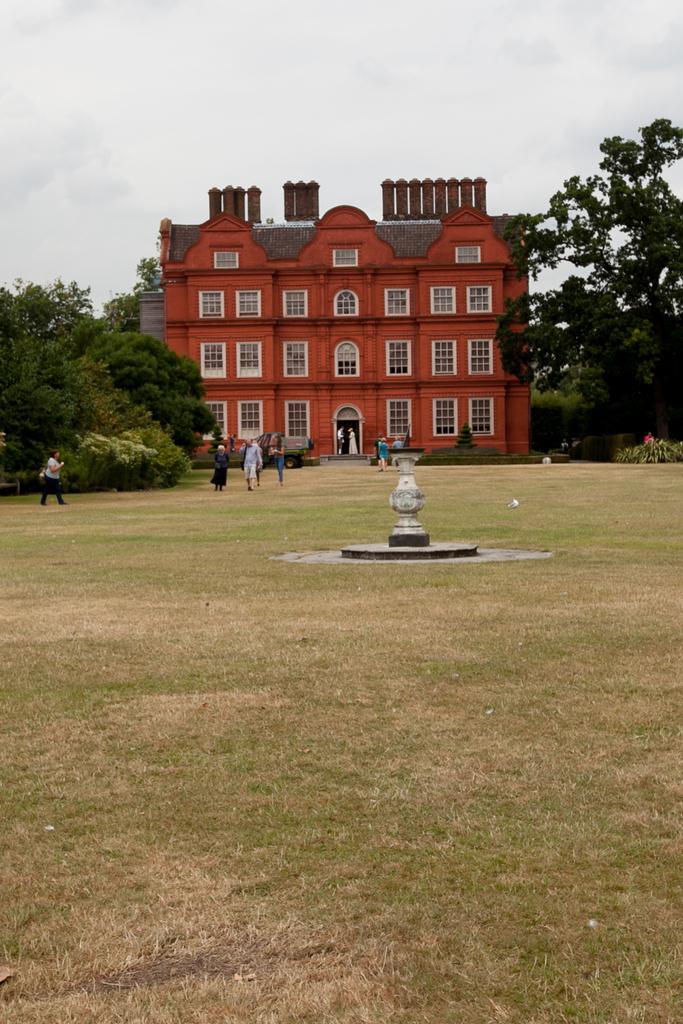Could you give a brief overview of what you see in this image? In this image we can see a building with some windows, there are some people, trees and a fountain, in the background we can see the sky. 